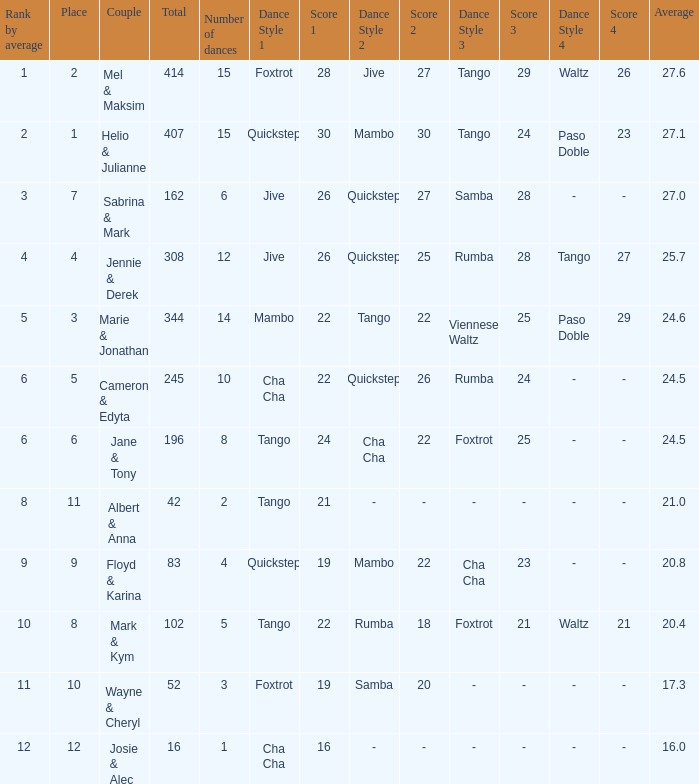What is the average when the rank by average is more than 12? None. 